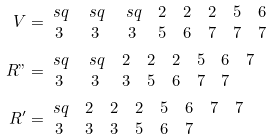<formula> <loc_0><loc_0><loc_500><loc_500>V & = \begin{matrix} \ s q & \ s q & \ s q & 2 & 2 & 2 & 5 & 6 \\ 3 & 3 & 3 & 5 & 6 & 7 & 7 & 7 \end{matrix} \\ R " & = \begin{matrix} \ s q & \ s q & 2 & 2 & 2 & 5 & 6 & 7 \\ 3 & 3 & 3 & 5 & 6 & 7 & 7 & \end{matrix} \\ R ^ { \prime } & = \begin{matrix} \ s q & 2 & 2 & 2 & 5 & 6 & 7 & 7 \\ 3 & 3 & 3 & 5 & 6 & 7 & & \end{matrix}</formula> 